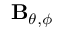<formula> <loc_0><loc_0><loc_500><loc_500>B _ { \theta , \phi }</formula> 